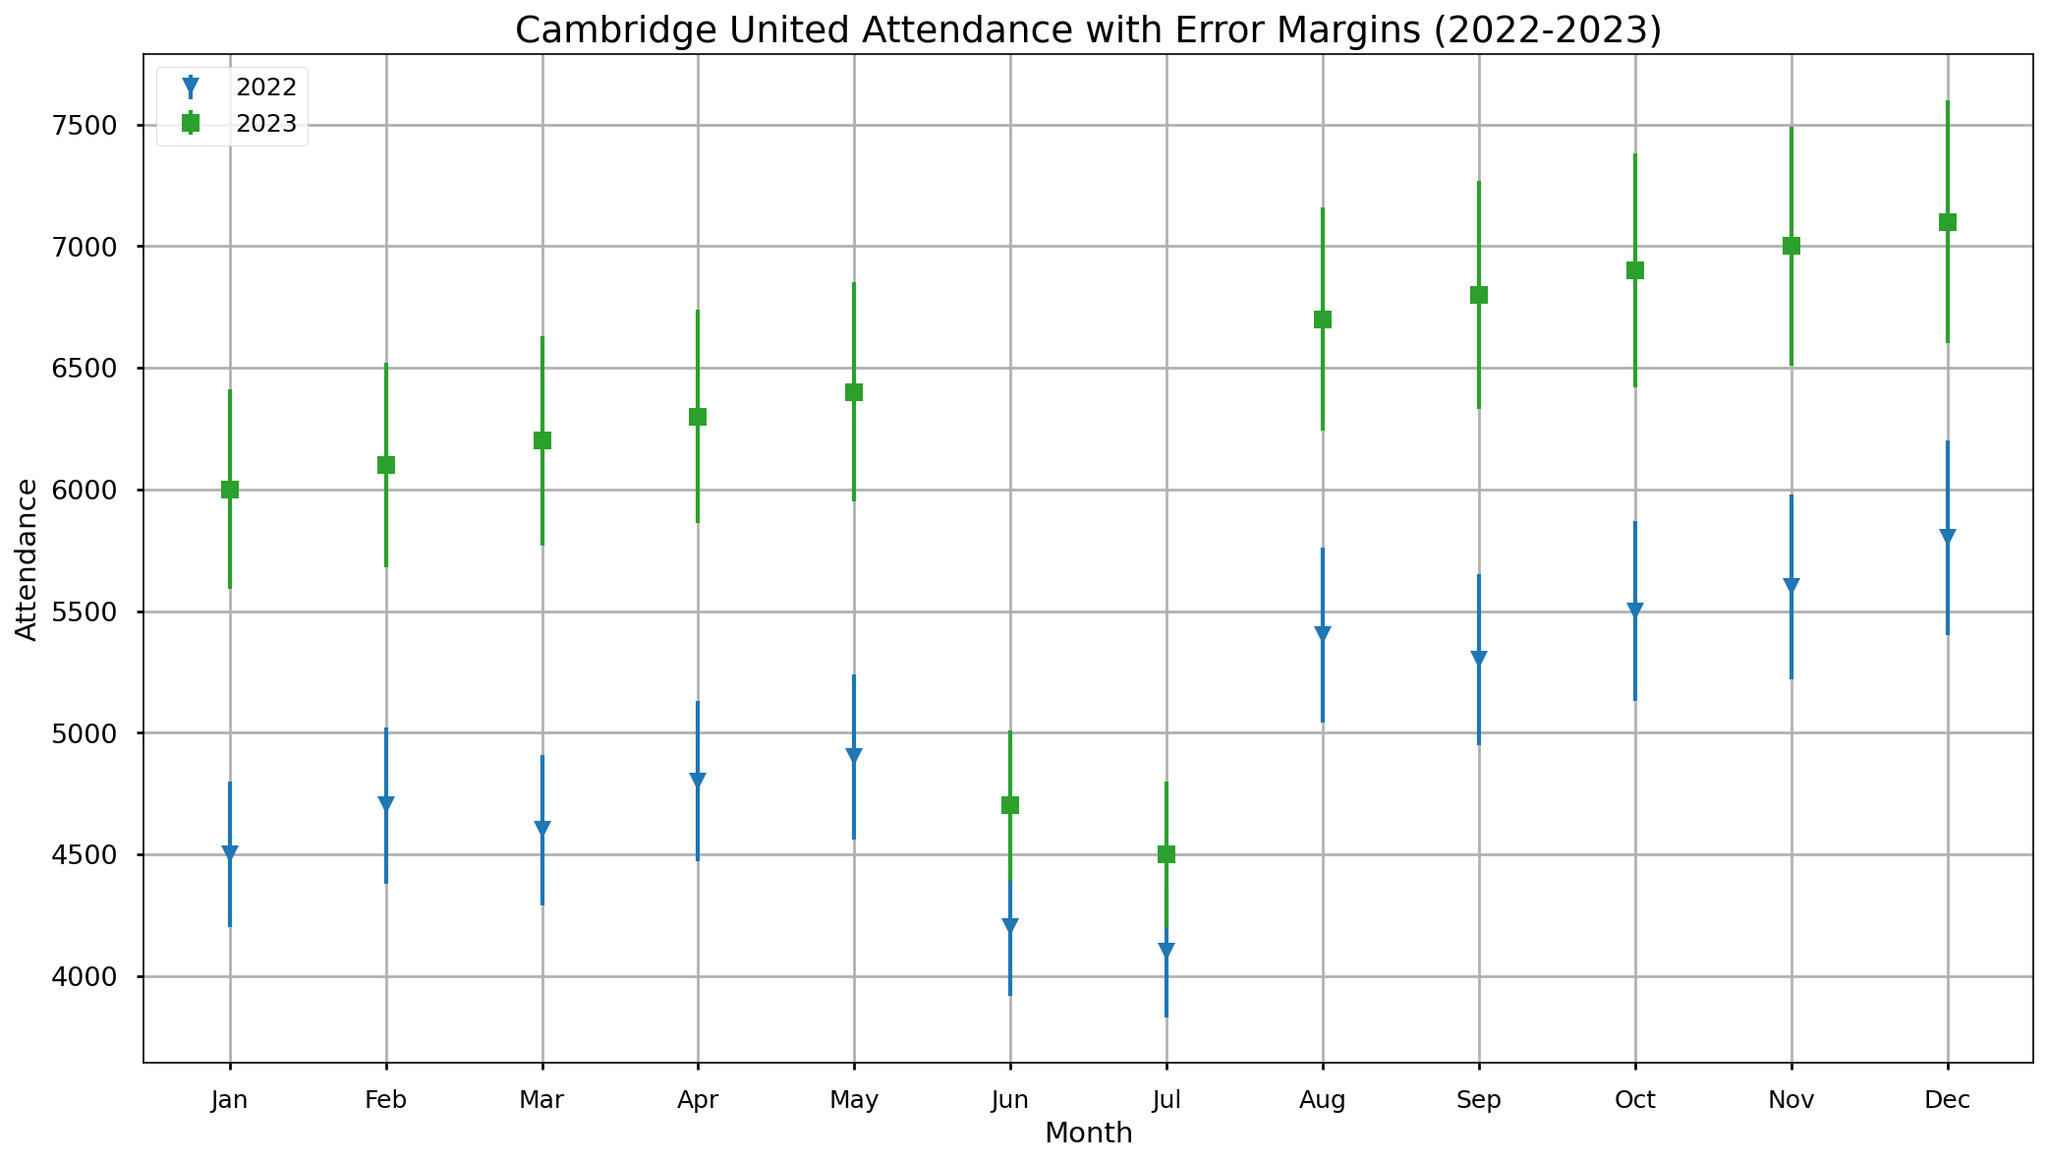Which season had the highest attendance in December? According to the chart, December 2023 had the highest attendance compared to December 2022. Visually, the attendance is represented by a higher point in December 2023.
Answer: 2023 What is the difference in attendance between August 2022 and August 2023? By looking at the attendance numbers for both August 2022 and August 2023, we can see that August 2022 had an attendance of 5400, while August 2023 had 6700. The difference is 6700 - 5400 = 1300.
Answer: 1300 How does the error margin for January 2023 compare to January 2022? The error margin for January 2023 is 410, while for January 2022 it is 300. So, the error margin in January 2023 is higher by 410 - 300 = 110.
Answer: 110 higher Which month in the year 2023 had the highest attendance? From the visual plot, December 2023 shows the highest point in terms of attendance for the year 2023.
Answer: December What is the average attendance over the months for the season 2022? Summing the attendance numbers for all months in 2022 and dividing by the number of months (12): (4500 + 4700 + 4600 + 4800 + 4900 + 4200 + 4100 + 5400 + 5300 + 5500 + 5600 + 5800) / 12 = 5092.
Answer: 5092 What is the trend in attendance from August to December for 2023? Between August and December 2023, the attendance is increasing steadily each month: August (6700), September (6800), October (6900), November (7000), December (7100).
Answer: Increasing Which month in 2022 shows the highest attendance with the smallest error margin? By observing both the attendance and the error bars, December 2022 has the highest attendance (5800) but does not necessarily have the smallest error margin. Let's compare till May, none of them has a higher attendance and a smaller error margin.
Answer: None Is there a month where the attendance in 2023 was exactly 500 higher than in 2022? Comparing both seasons visually, November 2023 had an attendance of 7000, and November 2022 had 5600, making it exactly 500 higher.
Answer: November 